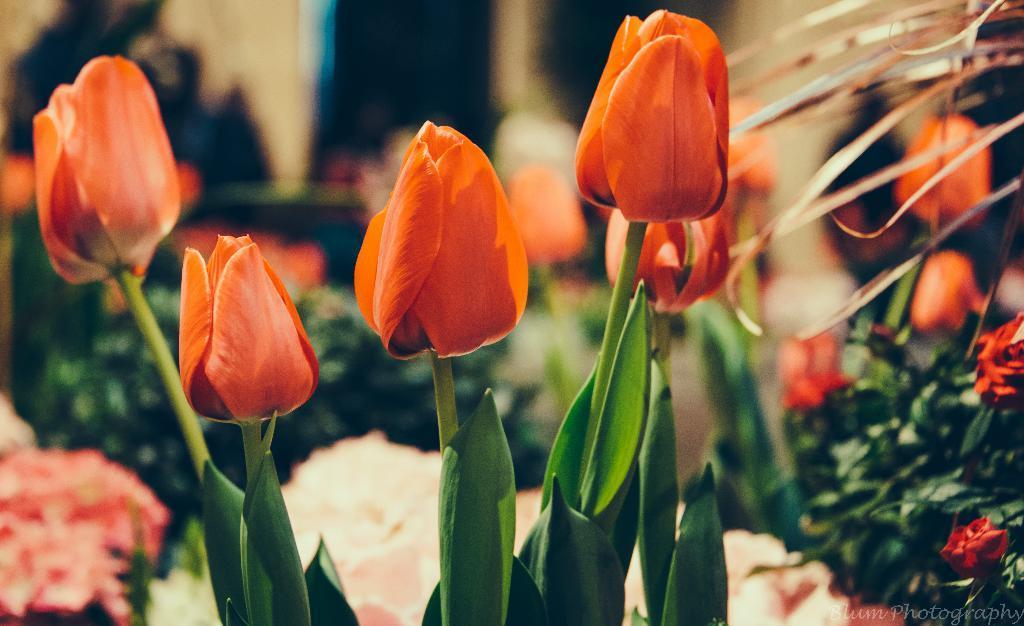How would you summarize this image in a sentence or two? In this image, we can see flowers. In the background, image is blurred. 